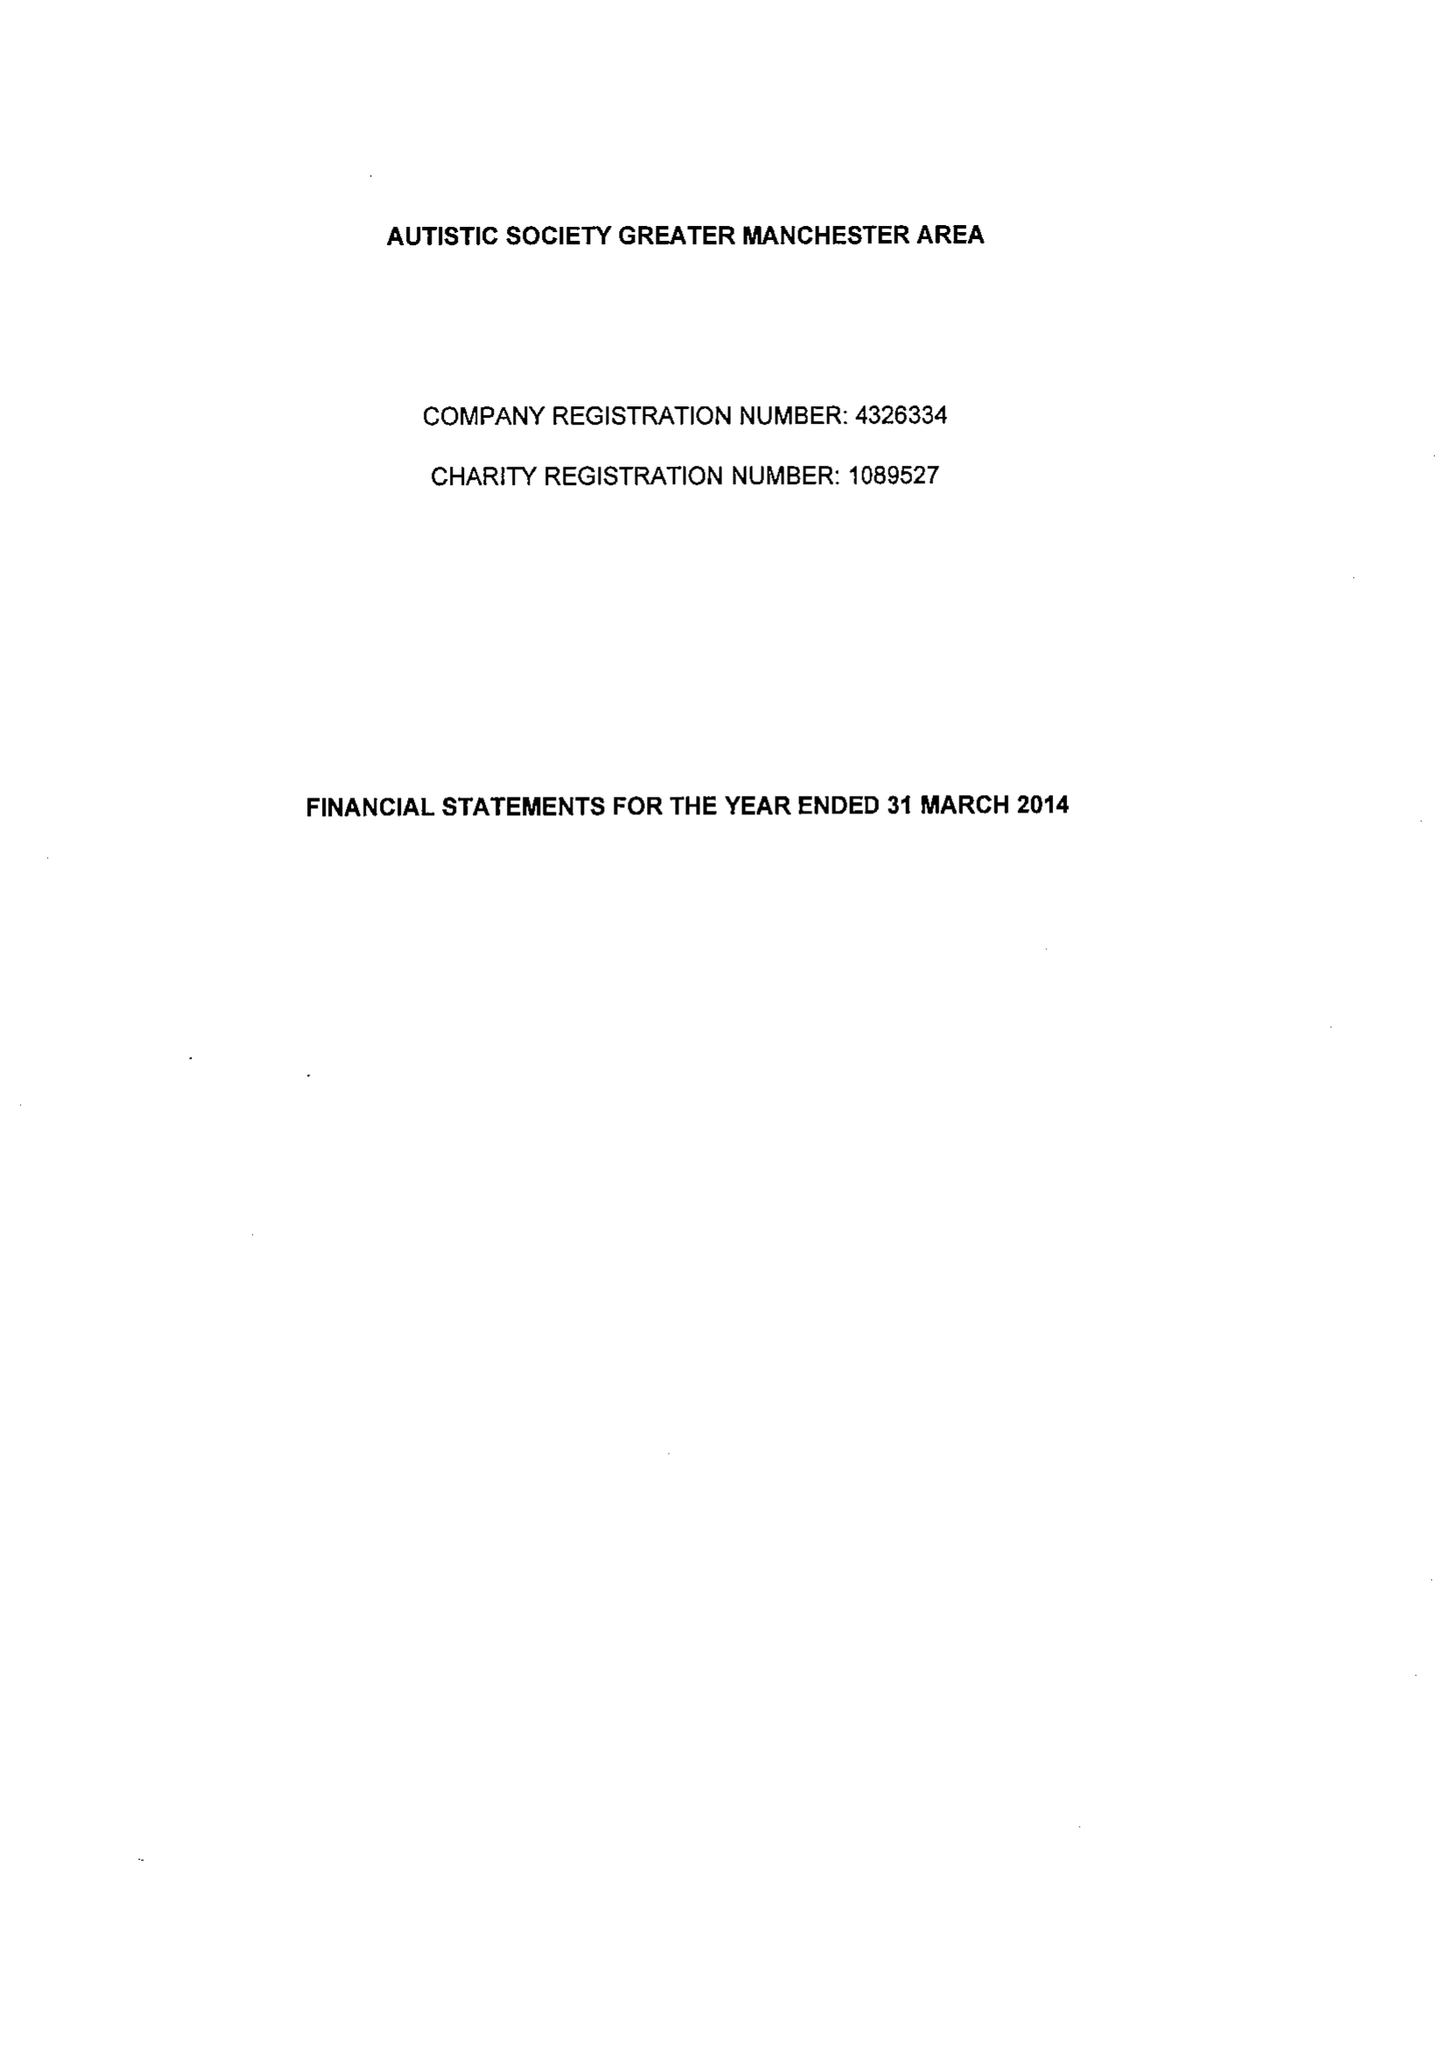What is the value for the charity_number?
Answer the question using a single word or phrase. 1089527 